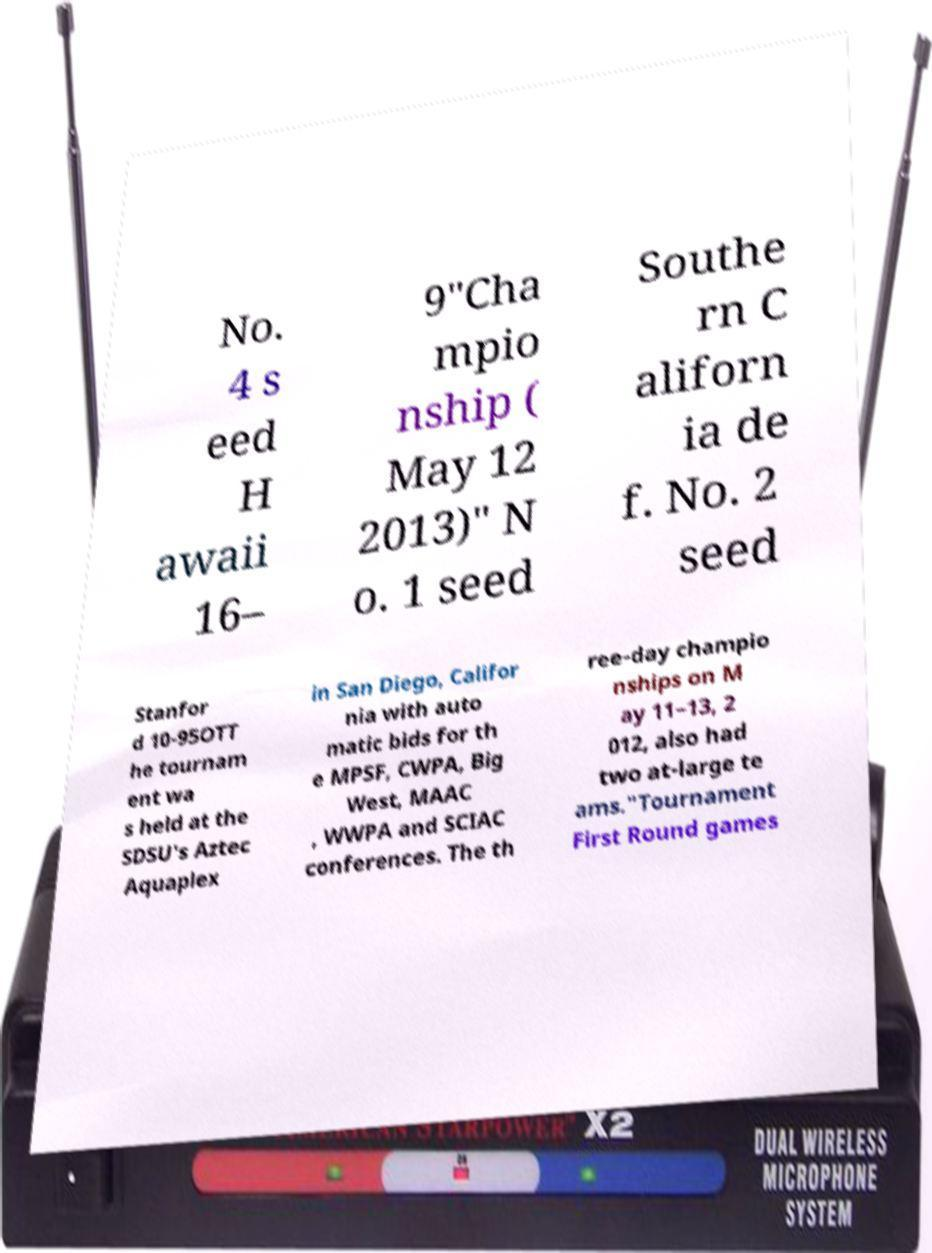Please identify and transcribe the text found in this image. No. 4 s eed H awaii 16– 9"Cha mpio nship ( May 12 2013)" N o. 1 seed Southe rn C aliforn ia de f. No. 2 seed Stanfor d 10-95OTT he tournam ent wa s held at the SDSU's Aztec Aquaplex in San Diego, Califor nia with auto matic bids for th e MPSF, CWPA, Big West, MAAC , WWPA and SCIAC conferences. The th ree-day champio nships on M ay 11–13, 2 012, also had two at-large te ams."Tournament First Round games 